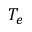<formula> <loc_0><loc_0><loc_500><loc_500>T _ { e }</formula> 